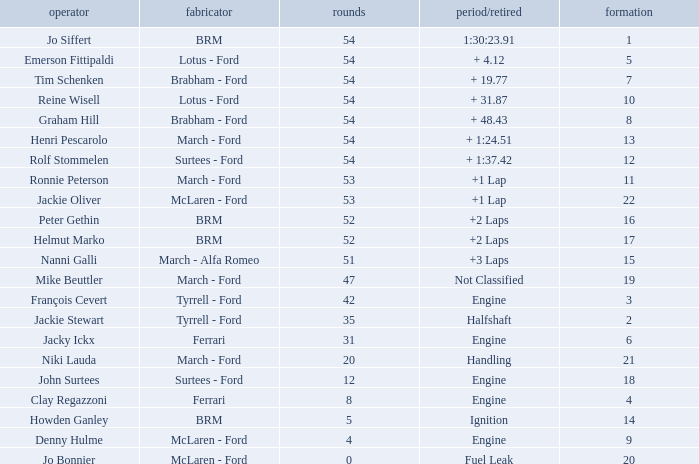How many laps for a grid larger than 1 with a Time/Retired of halfshaft? 35.0. 